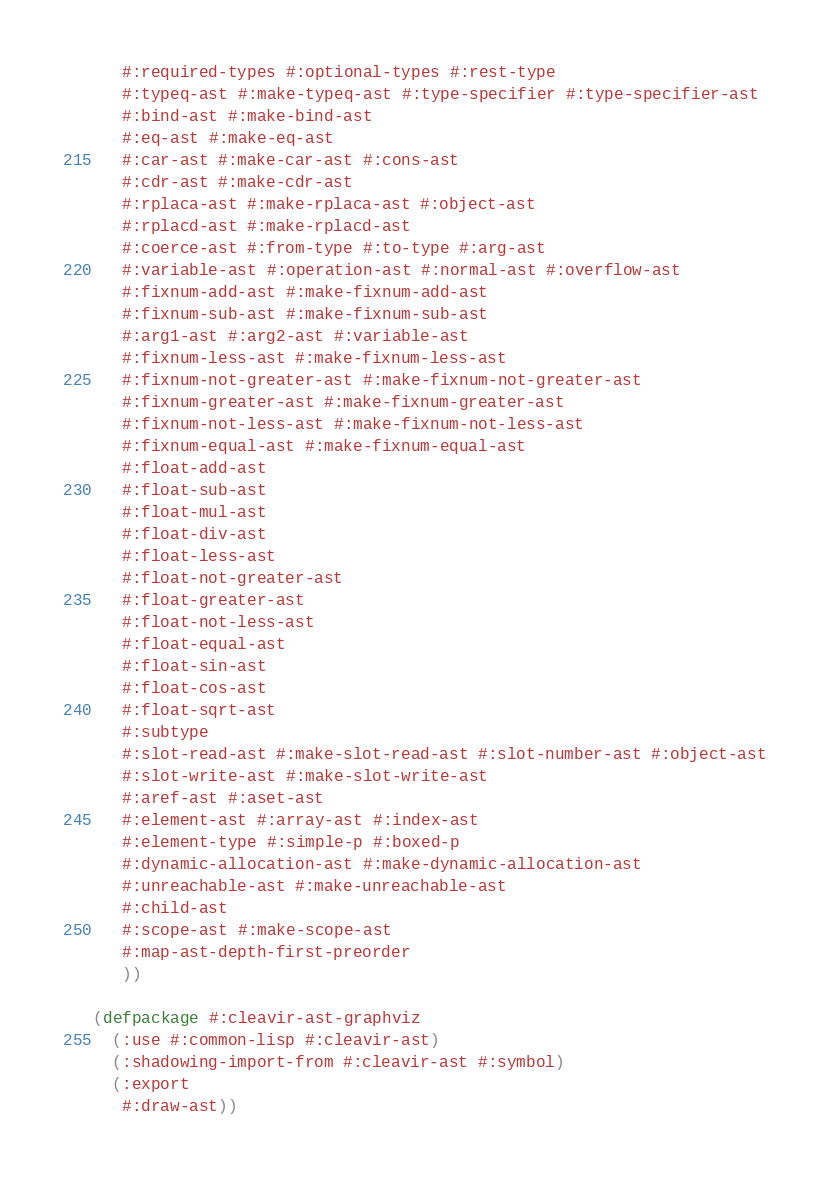Convert code to text. <code><loc_0><loc_0><loc_500><loc_500><_Lisp_>   #:required-types #:optional-types #:rest-type
   #:typeq-ast #:make-typeq-ast #:type-specifier #:type-specifier-ast
   #:bind-ast #:make-bind-ast
   #:eq-ast #:make-eq-ast
   #:car-ast #:make-car-ast #:cons-ast
   #:cdr-ast #:make-cdr-ast
   #:rplaca-ast #:make-rplaca-ast #:object-ast
   #:rplacd-ast #:make-rplacd-ast
   #:coerce-ast #:from-type #:to-type #:arg-ast
   #:variable-ast #:operation-ast #:normal-ast #:overflow-ast
   #:fixnum-add-ast #:make-fixnum-add-ast
   #:fixnum-sub-ast #:make-fixnum-sub-ast
   #:arg1-ast #:arg2-ast #:variable-ast
   #:fixnum-less-ast #:make-fixnum-less-ast
   #:fixnum-not-greater-ast #:make-fixnum-not-greater-ast
   #:fixnum-greater-ast #:make-fixnum-greater-ast
   #:fixnum-not-less-ast #:make-fixnum-not-less-ast
   #:fixnum-equal-ast #:make-fixnum-equal-ast
   #:float-add-ast
   #:float-sub-ast
   #:float-mul-ast
   #:float-div-ast
   #:float-less-ast
   #:float-not-greater-ast
   #:float-greater-ast
   #:float-not-less-ast
   #:float-equal-ast
   #:float-sin-ast
   #:float-cos-ast
   #:float-sqrt-ast
   #:subtype
   #:slot-read-ast #:make-slot-read-ast #:slot-number-ast #:object-ast
   #:slot-write-ast #:make-slot-write-ast
   #:aref-ast #:aset-ast
   #:element-ast #:array-ast #:index-ast
   #:element-type #:simple-p #:boxed-p
   #:dynamic-allocation-ast #:make-dynamic-allocation-ast
   #:unreachable-ast #:make-unreachable-ast
   #:child-ast
   #:scope-ast #:make-scope-ast
   #:map-ast-depth-first-preorder
   ))

(defpackage #:cleavir-ast-graphviz
  (:use #:common-lisp #:cleavir-ast)
  (:shadowing-import-from #:cleavir-ast #:symbol)
  (:export
   #:draw-ast))
</code> 